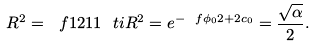Convert formula to latex. <formula><loc_0><loc_0><loc_500><loc_500>R ^ { 2 } = \ f { 1 2 } { 1 1 } \ t i { R } ^ { 2 } = e ^ { - \ f { \phi _ { 0 } } { 2 } + 2 c _ { 0 } } = \frac { \sqrt { \alpha } } { 2 } .</formula> 